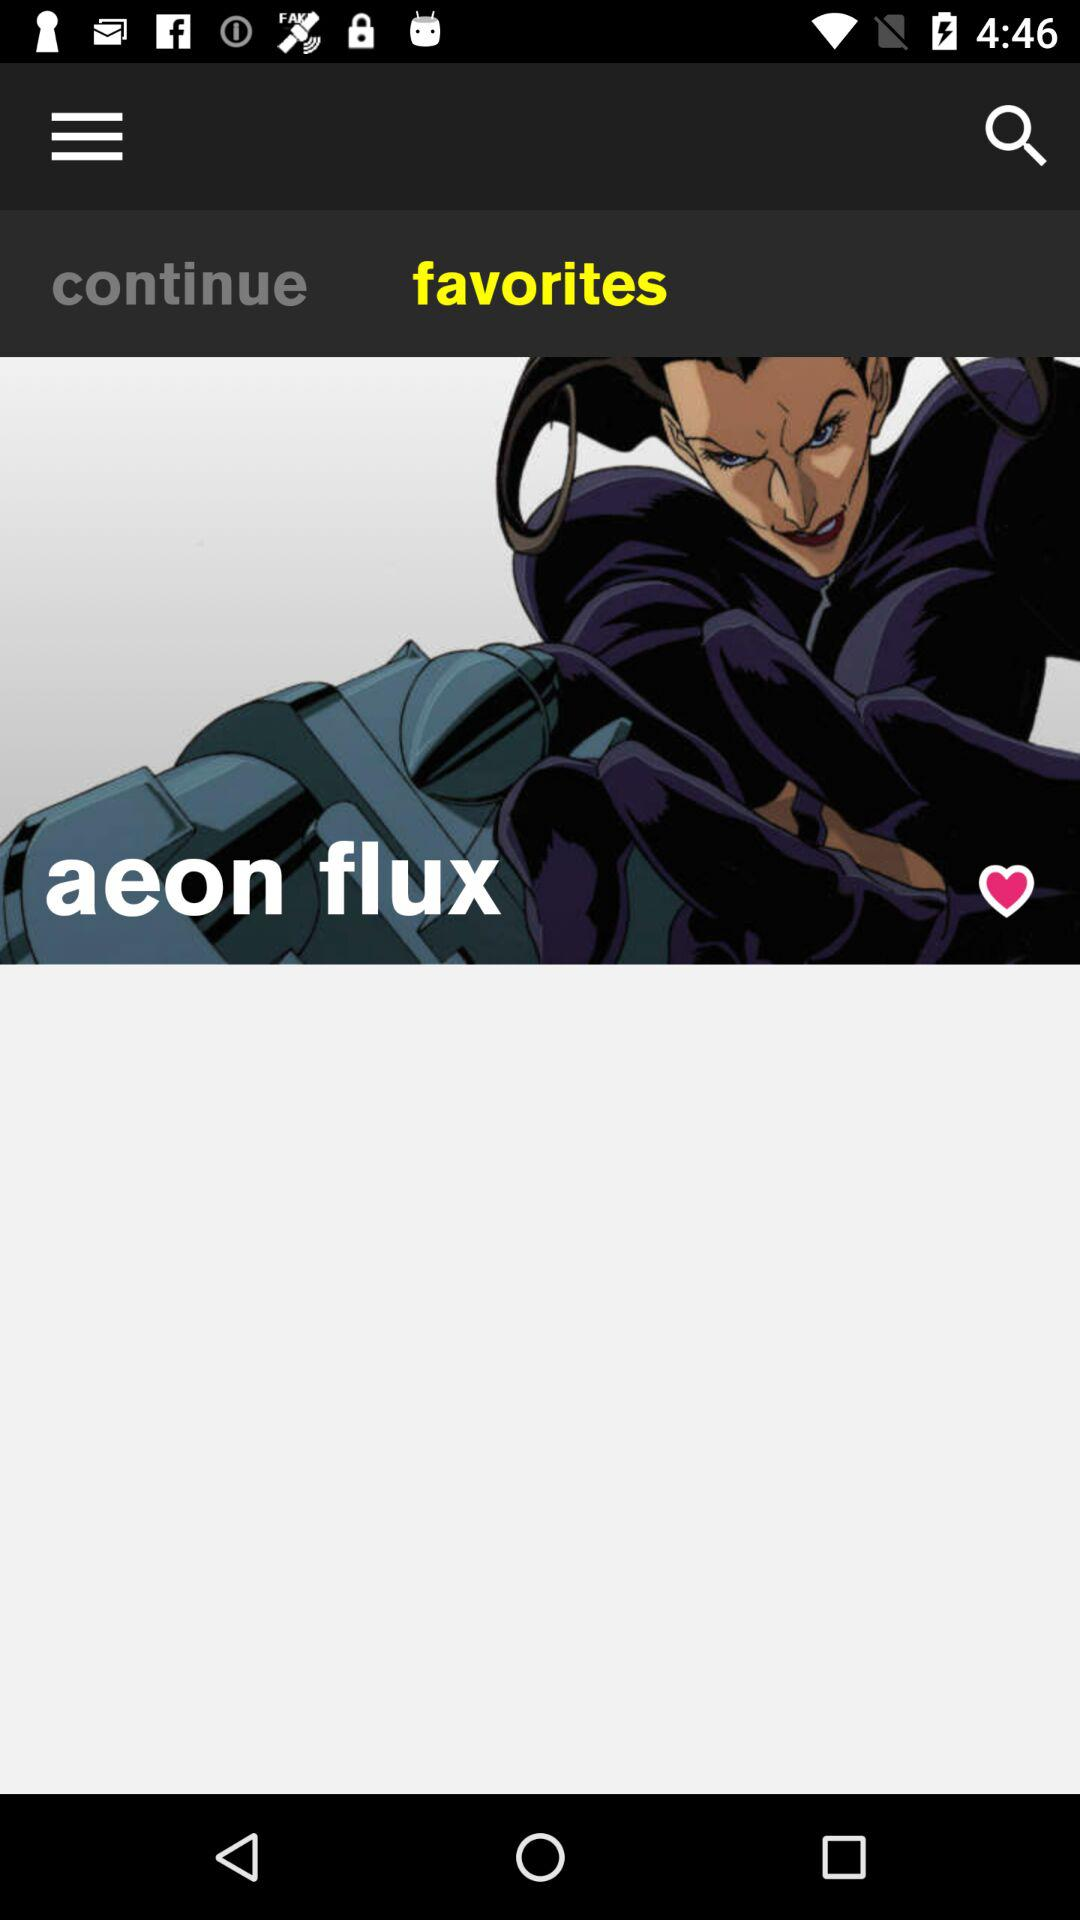What is the name of the user? The name of the user is Aeon Flux. 